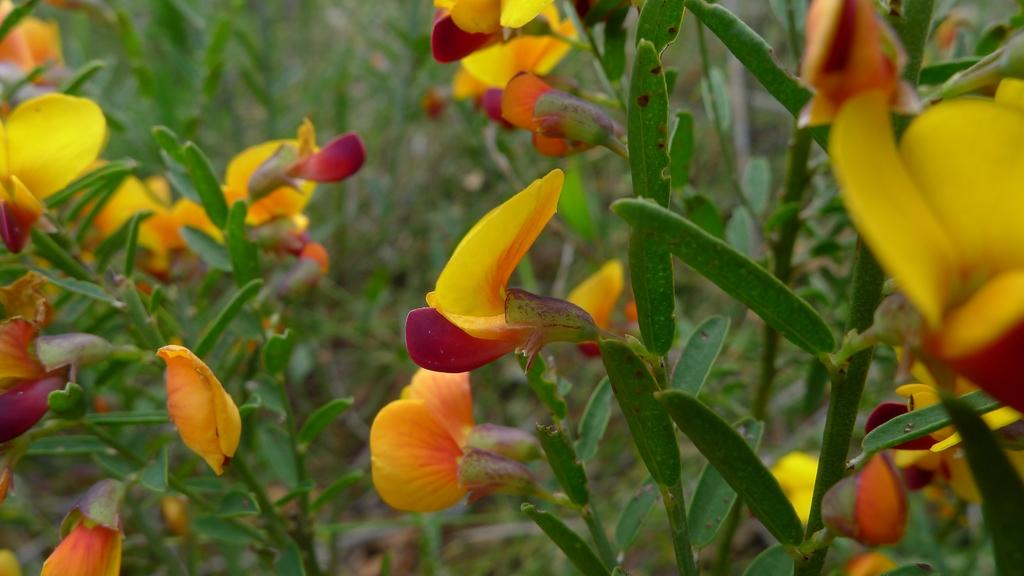What type of flora can be seen in the image? There are flowers in the image. What color are the flowers? The flowers are yellow. What else can be seen in the image besides the flowers? There are many plants in the image. What type of representative is sitting on the seat in the image? There is no representative or seat present in the image; it features flowers and plants. Can you tell me how many pigs are visible in the image? There are no pigs present in the image. 